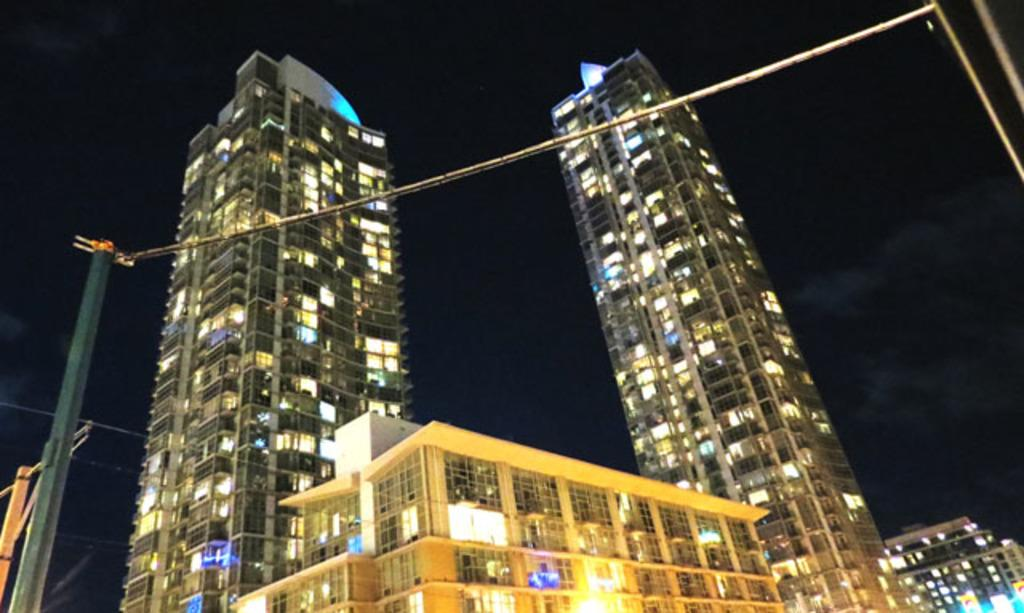What type of structures can be seen in the image? There are buildings in the image. Where are the poles located in the image? The poles are on the left side of the image. What type of animal can be seen wearing a shoe in the image? There is no animal or shoe present in the image. 